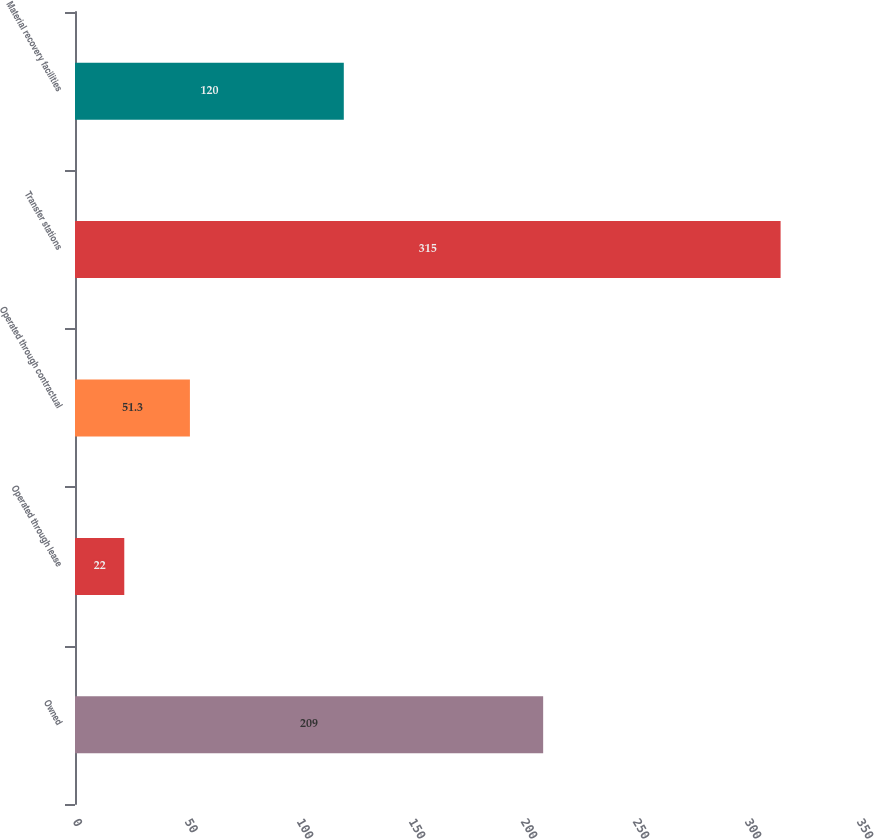<chart> <loc_0><loc_0><loc_500><loc_500><bar_chart><fcel>Owned<fcel>Operated through lease<fcel>Operated through contractual<fcel>Transfer stations<fcel>Material recovery facilities<nl><fcel>209<fcel>22<fcel>51.3<fcel>315<fcel>120<nl></chart> 